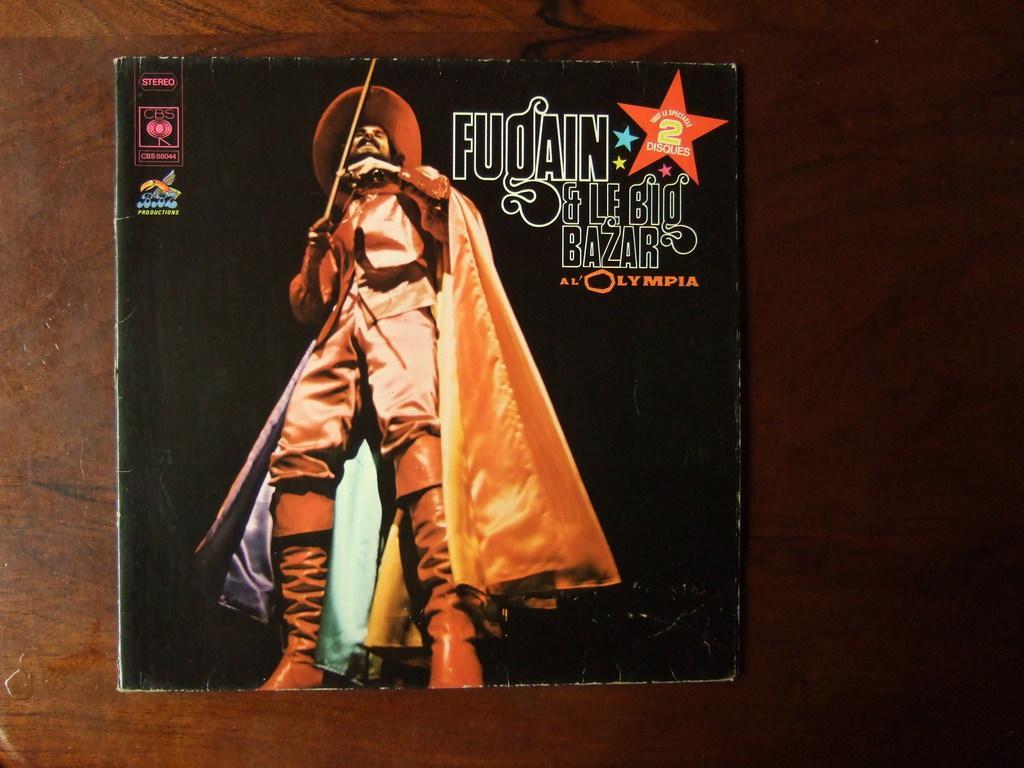Could you give a brief overview of what you see in this image? In this image I can see the cover page of the book. On the book I can see the person with brown color dress and hat. The person is holding the stick. I can see something is written on it. 